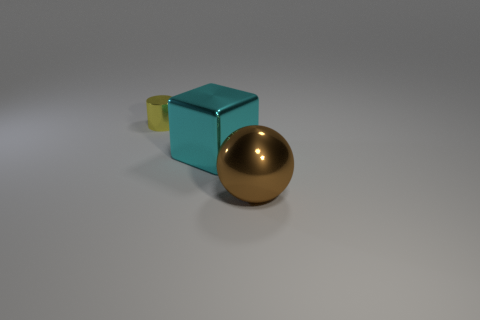Subtract all red cubes. Subtract all gray cylinders. How many cubes are left? 1 Add 3 cylinders. How many objects exist? 6 Subtract all blocks. How many objects are left? 2 Add 3 cyan metal cubes. How many cyan metal cubes exist? 4 Subtract 0 green cubes. How many objects are left? 3 Subtract all big brown shiny objects. Subtract all big brown balls. How many objects are left? 1 Add 2 brown shiny things. How many brown shiny things are left? 3 